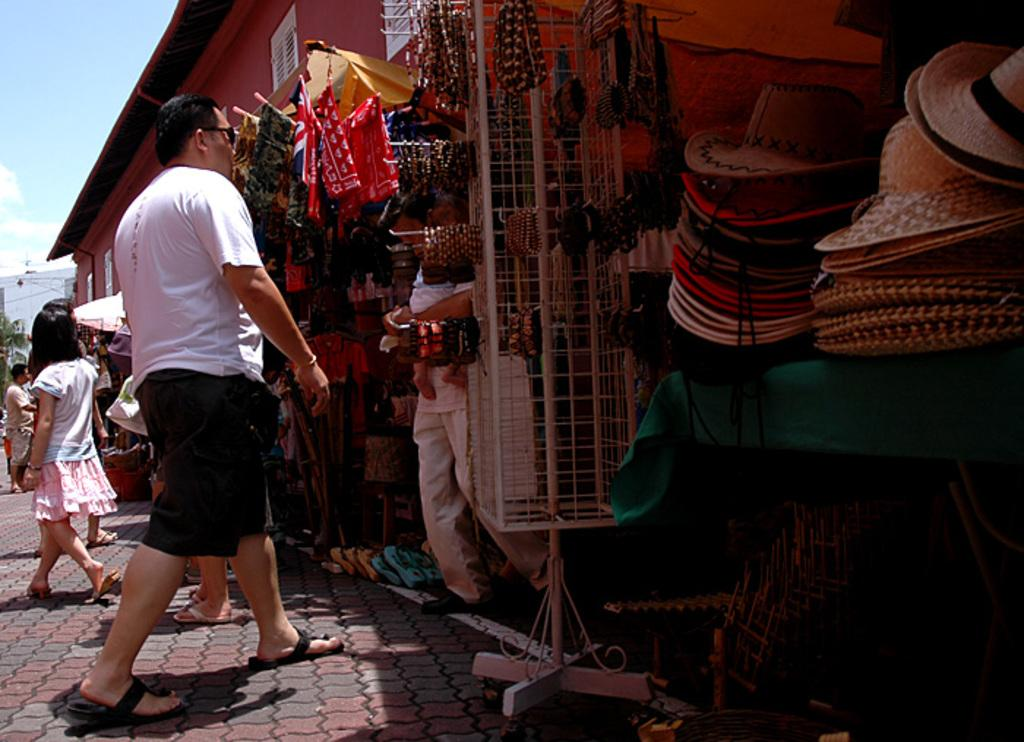What can be seen in the image? There is a crowd and shops in the image. Where is the image taken? The image is taken on a street. What is visible in the top left corner of the image? The sky is visible in the top left corner of the image. When was the image taken? The image is taken during the day. What color is the orange in the image? There is no orange present in the image. How many legs can be seen on the people in the crowd? It is not possible to count the legs of the people in the crowd from the image alone, as only the upper bodies are visible. 